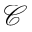<formula> <loc_0><loc_0><loc_500><loc_500>\mathcal { C }</formula> 